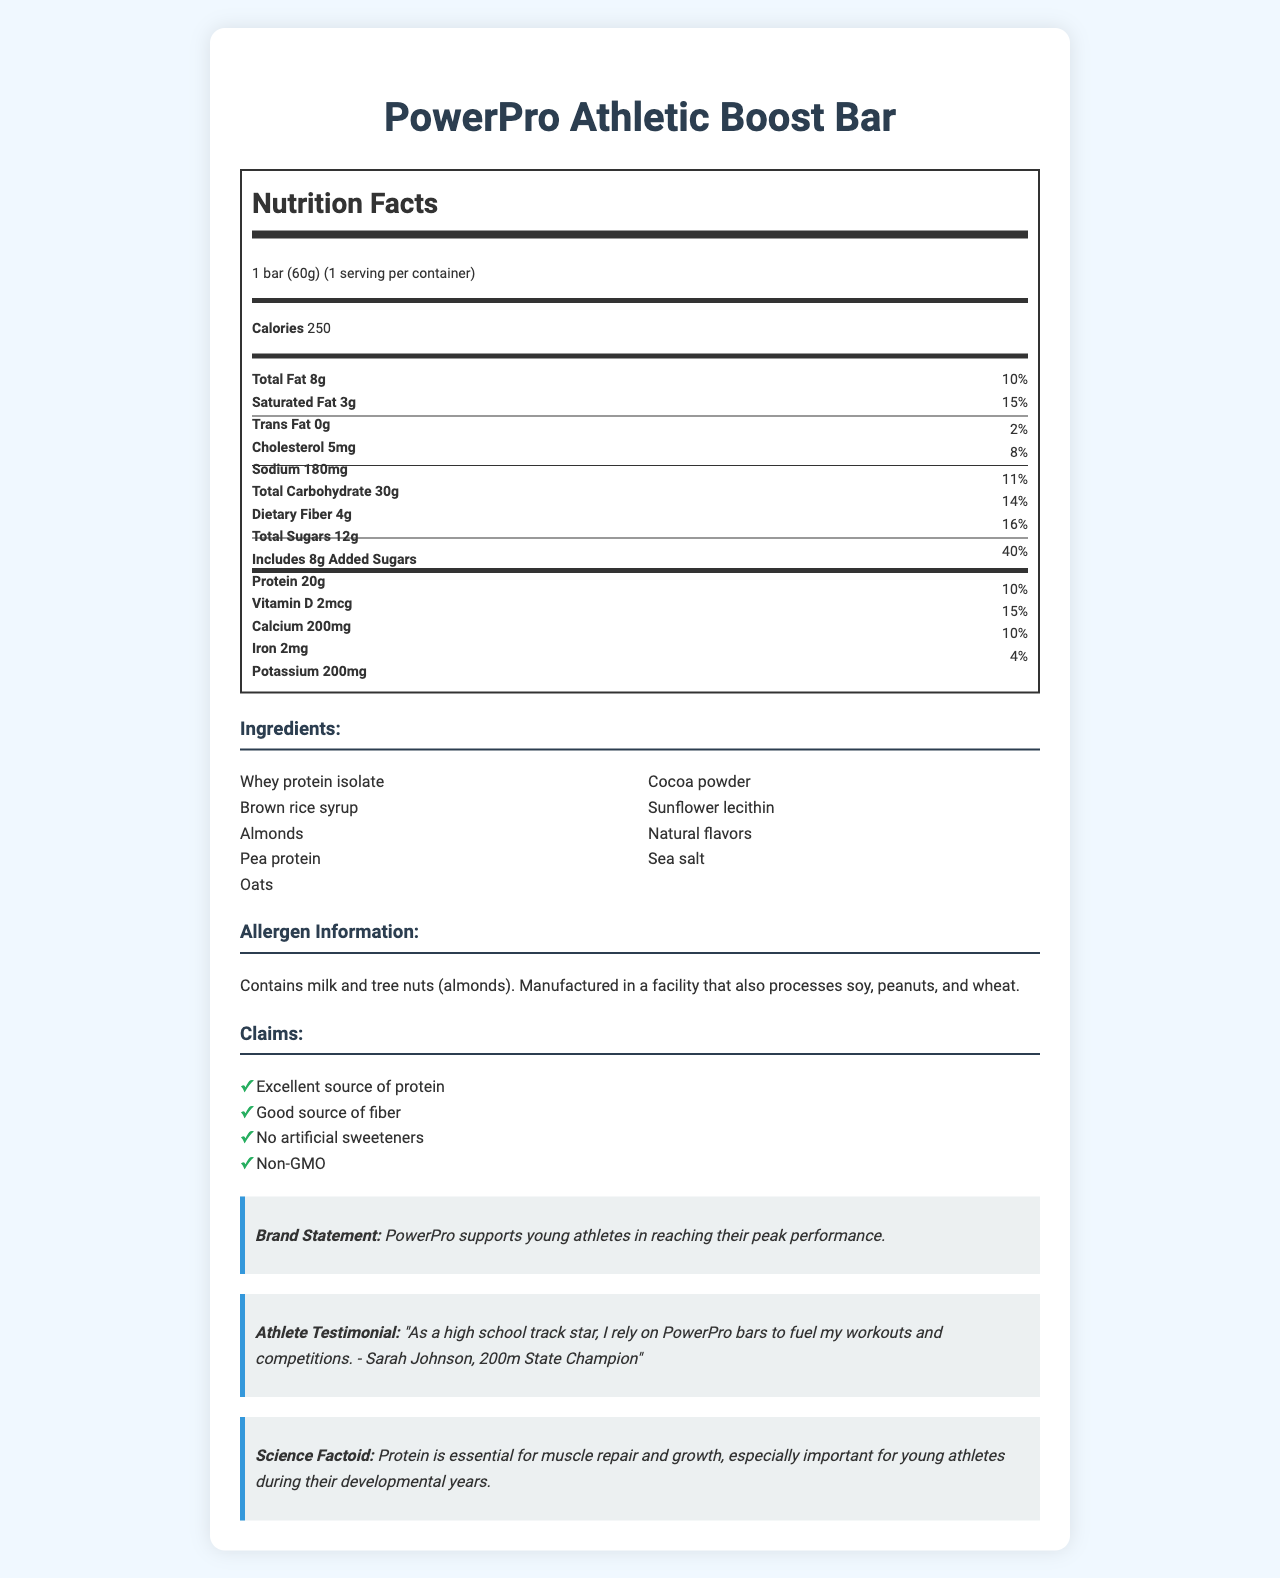what is the serving size of the PowerPro Athletic Boost Bar? The serving size is explicitly stated in the document as "1 bar (60g)".
Answer: 1 bar (60g) how many calories are in one PowerPro Athletic Boost Bar? The document lists the calories in one serving as 250.
Answer: 250 what is the amount of protein in one serving of the PowerPro Athletic Boost Bar? The nutrition label specifies that one serving contains 20g of protein.
Answer: 20g from which ingredient is the primary source of protein derived? The ingredient list starts with "Whey protein isolate," typically indicating it is the main ingredient and the primary source of protein.
Answer: Whey protein isolate what are the allergen components mentioned in the document? The allergen information states that the bar contains milk and tree nuts (almonds).
Answer: Milk, tree nuts (almonds) what percentage of the daily value of saturated fat is present in one PowerPro Athletic Boost Bar? The label specifies that the bar contains 15% of the daily value of saturated fat.
Answer: 15% how many grams of dietary fiber does the PowerPro Athletic Boost Bar contain? A. 2g B. 3g C. 4g D. 5g The nutrition label clearly indicates that one serving includes 4g of dietary fiber.
Answer: C. 4g which claim is NOT made in the document about the PowerPro Athletic Boost Bar? A. Excellent source of protein B. Low in sodium C. Non-GMO D. No artificial sweeteners The claims listed in the document do not mention the bar being low in sodium.
Answer: B. Low in sodium is the PowerPro Athletic Boost Bar free from artificial sweeteners? The claims section clearly states "No artificial sweeteners."
Answer: Yes summarize the main features and nutritional highlights of the PowerPro Athletic Boost Bar. This summary captures the central aspects and nutritional points as illustrated in the document.
Answer: A protein-rich bar with 250 calories, 20g of protein, and claims of no artificial sweeteners, good fiber content, and non-GMO. Contains milk and tree nuts. what is the testimonial from an athlete about the PowerPro Athletic Boost Bar? The athlete testimonial section of the document features this quote.
Answer: "As a high school track star, I rely on PowerPro bars to fuel my workouts and competitions. - Sarah Johnson, 200m State Champion" what is the total amount of sugar, including added sugars, in one PowerPro Athletic Boost Bar? The document specifies 12g of total sugars, including 8g of added sugars, making the total sugar content evident.
Answer: 12g total sugars, 8g added sugars what percentage of the daily value of calcium does the PowerPro Athletic Boost Bar provide? The nutrition label indicates that the bar offers 15% of the daily value of calcium.
Answer: 15% how much sodium is in one PowerPro Athletic Boost Bar? The nutrition label shows that one serving contains 180mg of sodium.
Answer: 180mg what is the exact number of vitamins and minerals listed on the PowerPro Athletic Boost Bar’s nutrition label? The document includes Vitamin D, Calcium, Iron, and Potassium in the nutrition label.
Answer: Four (Vitamin D, Calcium, Iron, Potassium) does the PowerPro Athletic Boost Bar contain any soy? While the document lists the allergens, it mentions only that it is manufactured in a facility that also processes soy, without specifying if the bar itself contains soy.
Answer: Cannot be determined 